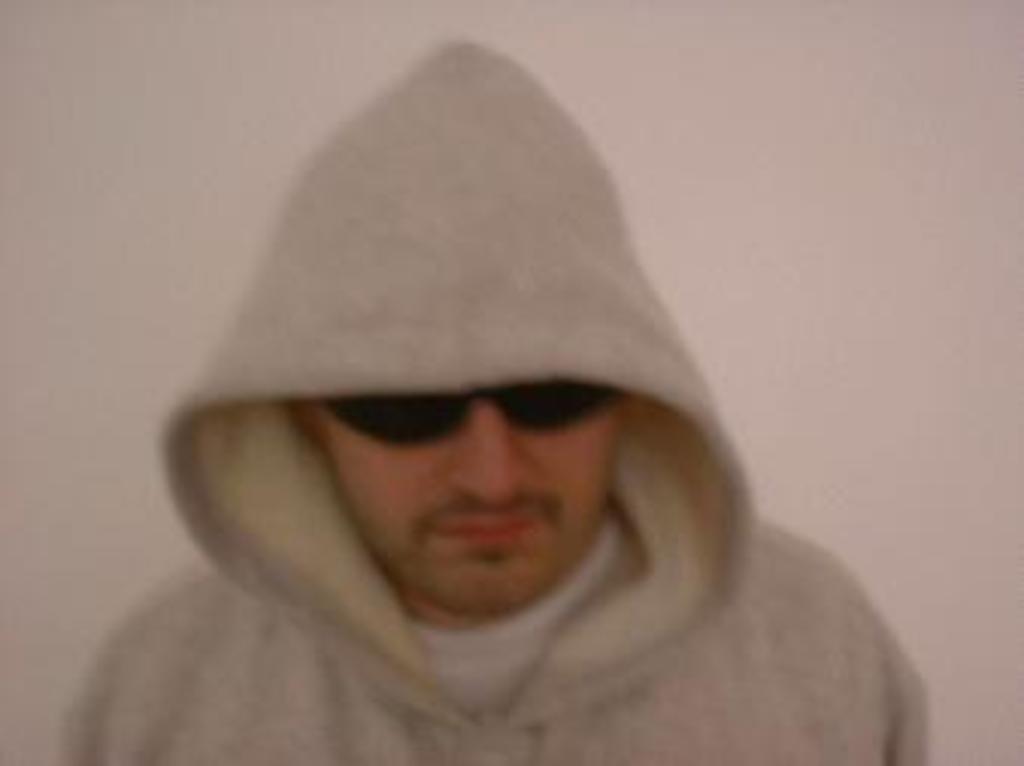Please provide a concise description of this image. In this image we can see the man wearing the black color glasses and in the background we can see the plain wall. 